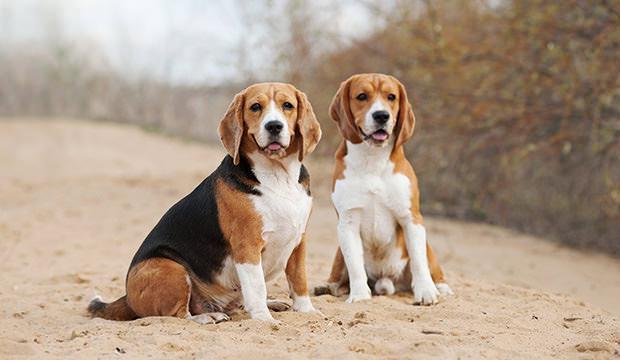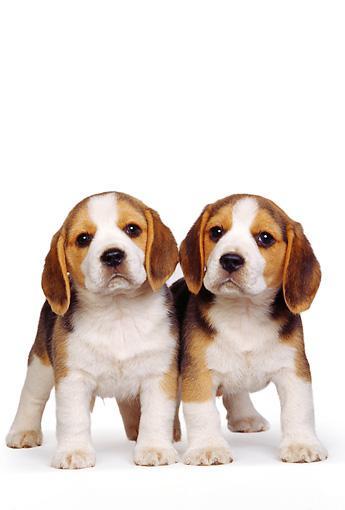The first image is the image on the left, the second image is the image on the right. Given the left and right images, does the statement "There are 2 dogs standing on all fours in the right image." hold true? Answer yes or no. Yes. 